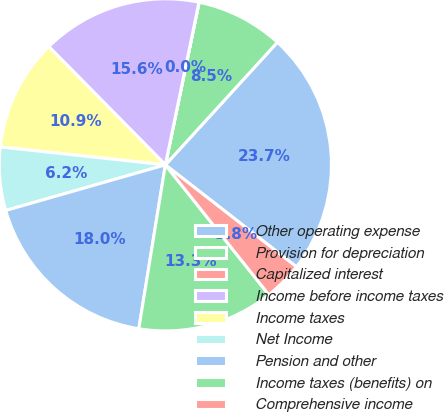Convert chart. <chart><loc_0><loc_0><loc_500><loc_500><pie_chart><fcel>Other operating expense<fcel>Provision for depreciation<fcel>Capitalized interest<fcel>Income before income taxes<fcel>Income taxes<fcel>Net Income<fcel>Pension and other<fcel>Income taxes (benefits) on<fcel>Comprehensive income<nl><fcel>23.74%<fcel>8.52%<fcel>0.02%<fcel>15.63%<fcel>10.89%<fcel>6.15%<fcel>18.01%<fcel>13.26%<fcel>3.77%<nl></chart> 